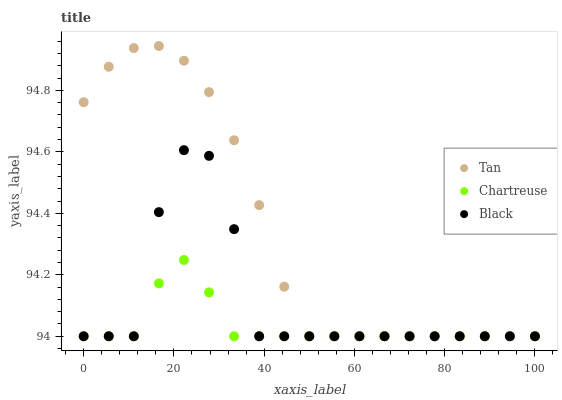Does Chartreuse have the minimum area under the curve?
Answer yes or no. Yes. Does Tan have the maximum area under the curve?
Answer yes or no. Yes. Does Black have the minimum area under the curve?
Answer yes or no. No. Does Black have the maximum area under the curve?
Answer yes or no. No. Is Chartreuse the smoothest?
Answer yes or no. Yes. Is Black the roughest?
Answer yes or no. Yes. Is Black the smoothest?
Answer yes or no. No. Is Chartreuse the roughest?
Answer yes or no. No. Does Tan have the lowest value?
Answer yes or no. Yes. Does Tan have the highest value?
Answer yes or no. Yes. Does Black have the highest value?
Answer yes or no. No. Does Chartreuse intersect Tan?
Answer yes or no. Yes. Is Chartreuse less than Tan?
Answer yes or no. No. Is Chartreuse greater than Tan?
Answer yes or no. No. 